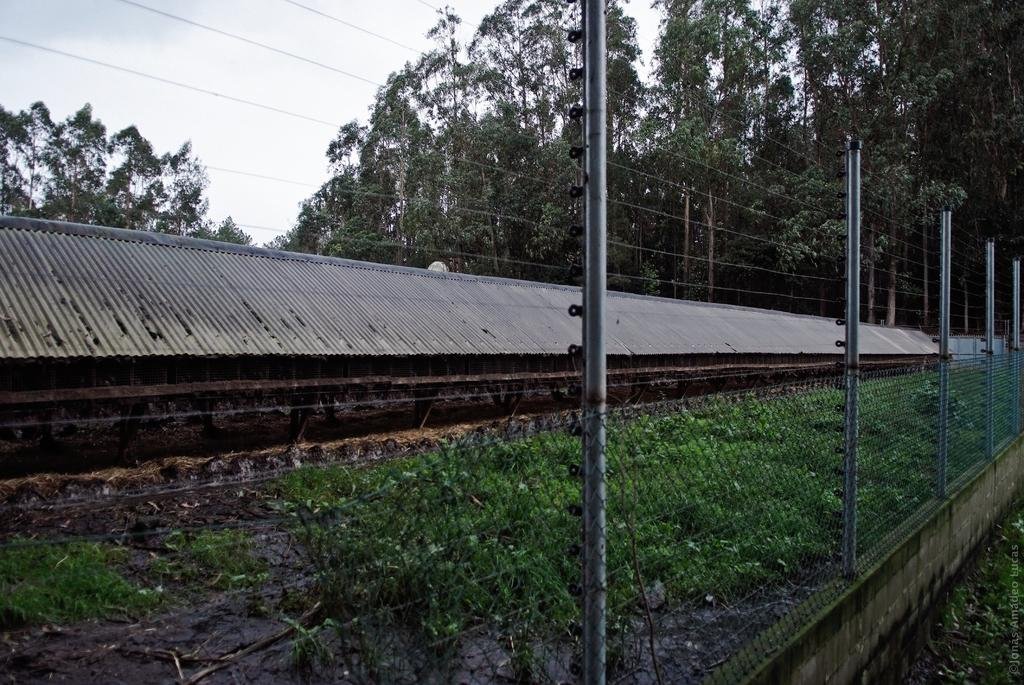What type of structure is present in the image? There is a long shed in the image. What can be seen on the ground in the image? There are plants on the ground in the image. What type of barrier is visible in the image? There is a fence in the image. What is visible in the background of the image? There are trees and the sky in the background of the image. Where is the sister in the image? There is no sister present in the image. What type of party is being held in the image? There is no party depicted in the image. 